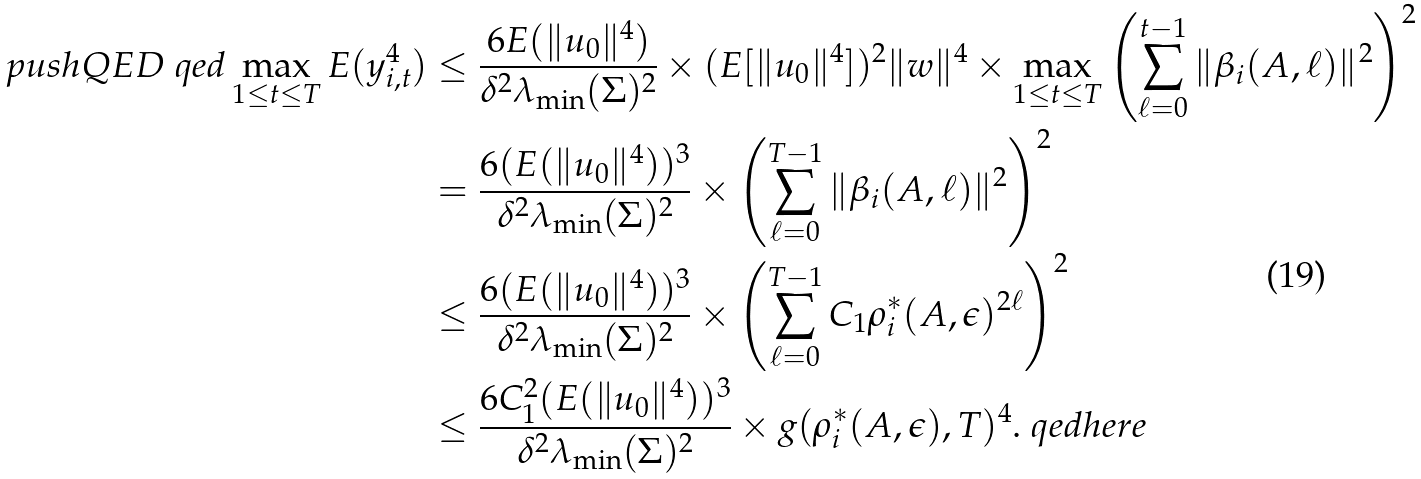<formula> <loc_0><loc_0><loc_500><loc_500>\ p u s h Q E D { \ q e d } \max _ { 1 \leq t \leq T } E ( y _ { i , t } ^ { 4 } ) & \leq \frac { 6 E ( \| u _ { 0 } \| ^ { 4 } ) } { \delta ^ { 2 } \lambda _ { \min } ( \Sigma ) ^ { 2 } } \times ( E [ \| u _ { 0 } \| ^ { 4 } ] ) ^ { 2 } \| w \| ^ { 4 } \times \max _ { 1 \leq t \leq T } \left ( \sum _ { \ell = 0 } ^ { t - 1 } \| \beta _ { i } ( A , \ell ) \| ^ { 2 } \right ) ^ { 2 } \\ & = \frac { 6 ( E ( \| u _ { 0 } \| ^ { 4 } ) ) ^ { 3 } } { \delta ^ { 2 } \lambda _ { \min } ( \Sigma ) ^ { 2 } } \times \left ( \sum _ { \ell = 0 } ^ { T - 1 } \| \beta _ { i } ( A , \ell ) \| ^ { 2 } \right ) ^ { 2 } \\ & \leq \frac { 6 ( E ( \| u _ { 0 } \| ^ { 4 } ) ) ^ { 3 } } { \delta ^ { 2 } \lambda _ { \min } ( \Sigma ) ^ { 2 } } \times \left ( \sum _ { \ell = 0 } ^ { T - 1 } C _ { 1 } \rho _ { i } ^ { * } ( A , \epsilon ) ^ { 2 \ell } \right ) ^ { 2 } \\ & \leq \frac { 6 C _ { 1 } ^ { 2 } ( E ( \| u _ { 0 } \| ^ { 4 } ) ) ^ { 3 } } { \delta ^ { 2 } \lambda _ { \min } ( \Sigma ) ^ { 2 } } \times g ( \rho _ { i } ^ { * } ( A , \epsilon ) , T ) ^ { 4 } . \ q e d h e r e</formula> 